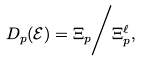<formula> <loc_0><loc_0><loc_500><loc_500>D _ { p } ( \mathcal { E } ) = \Xi _ { p } \Big / \Xi _ { p } ^ { \ell } ,</formula> 